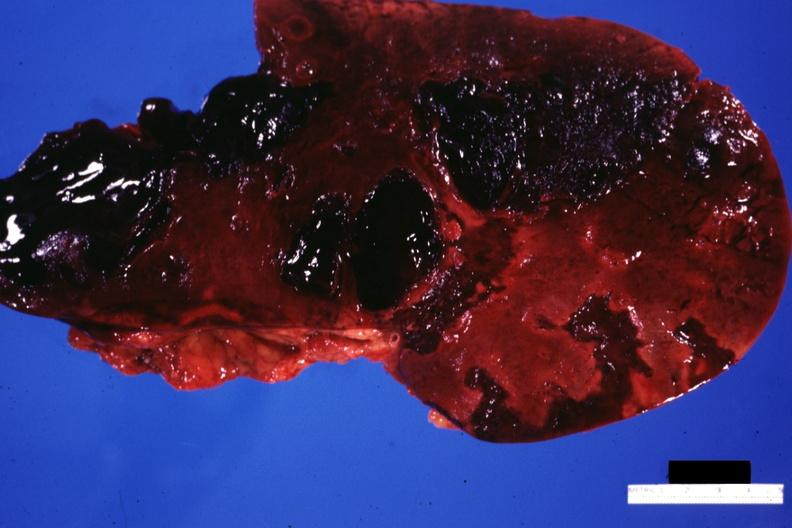s hepatobiliary present?
Answer the question using a single word or phrase. Yes 